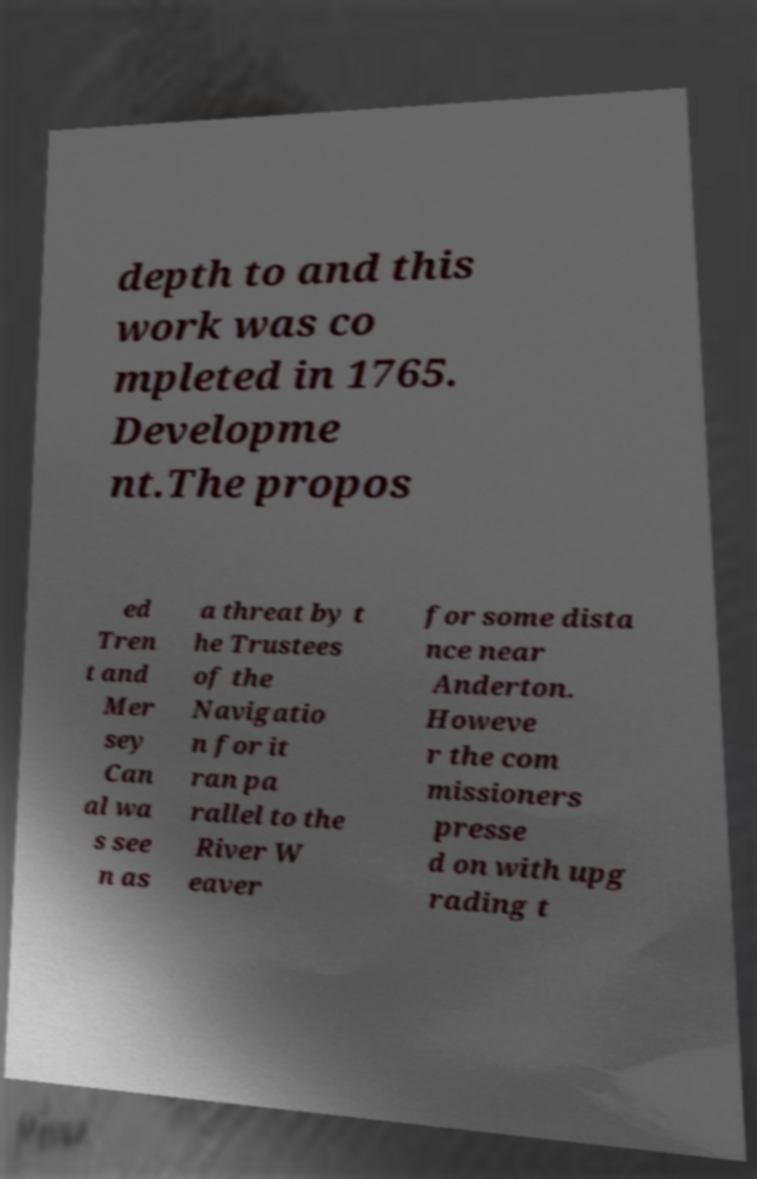For documentation purposes, I need the text within this image transcribed. Could you provide that? depth to and this work was co mpleted in 1765. Developme nt.The propos ed Tren t and Mer sey Can al wa s see n as a threat by t he Trustees of the Navigatio n for it ran pa rallel to the River W eaver for some dista nce near Anderton. Howeve r the com missioners presse d on with upg rading t 